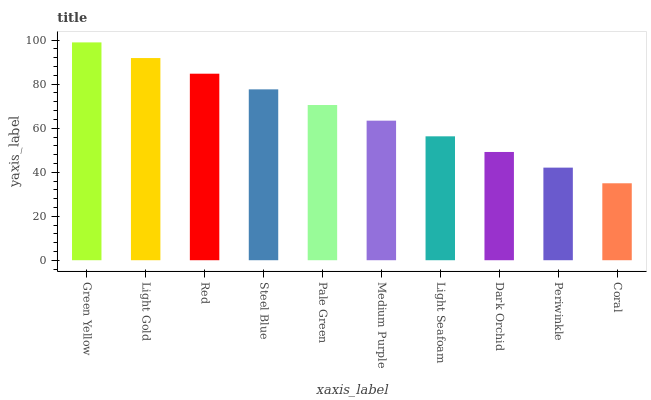Is Coral the minimum?
Answer yes or no. Yes. Is Green Yellow the maximum?
Answer yes or no. Yes. Is Light Gold the minimum?
Answer yes or no. No. Is Light Gold the maximum?
Answer yes or no. No. Is Green Yellow greater than Light Gold?
Answer yes or no. Yes. Is Light Gold less than Green Yellow?
Answer yes or no. Yes. Is Light Gold greater than Green Yellow?
Answer yes or no. No. Is Green Yellow less than Light Gold?
Answer yes or no. No. Is Pale Green the high median?
Answer yes or no. Yes. Is Medium Purple the low median?
Answer yes or no. Yes. Is Steel Blue the high median?
Answer yes or no. No. Is Green Yellow the low median?
Answer yes or no. No. 